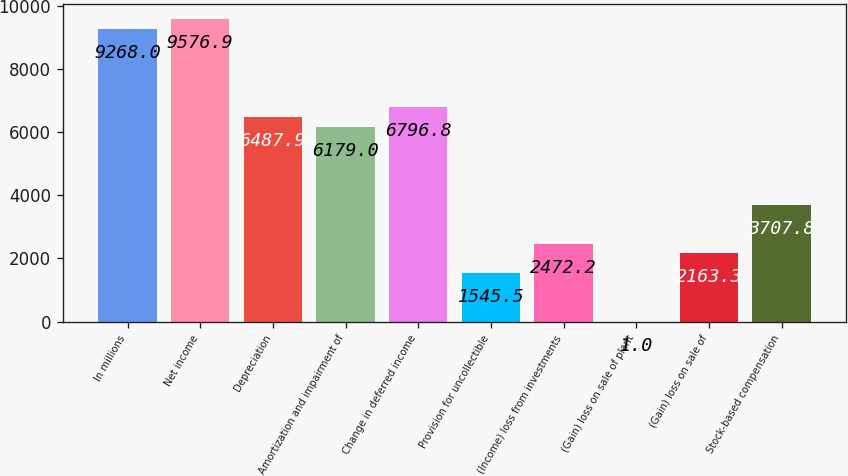Convert chart. <chart><loc_0><loc_0><loc_500><loc_500><bar_chart><fcel>In millions<fcel>Net income<fcel>Depreciation<fcel>Amortization and impairment of<fcel>Change in deferred income<fcel>Provision for uncollectible<fcel>(Income) loss from investments<fcel>(Gain) loss on sale of plant<fcel>(Gain) loss on sale of<fcel>Stock-based compensation<nl><fcel>9268<fcel>9576.9<fcel>6487.9<fcel>6179<fcel>6796.8<fcel>1545.5<fcel>2472.2<fcel>1<fcel>2163.3<fcel>3707.8<nl></chart> 